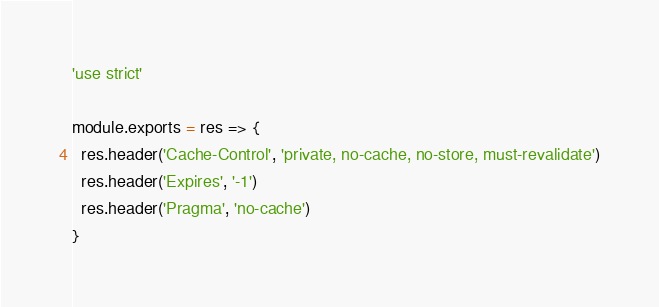Convert code to text. <code><loc_0><loc_0><loc_500><loc_500><_JavaScript_>'use strict'

module.exports = res => {
  res.header('Cache-Control', 'private, no-cache, no-store, must-revalidate')
  res.header('Expires', '-1')
  res.header('Pragma', 'no-cache')
}
</code> 